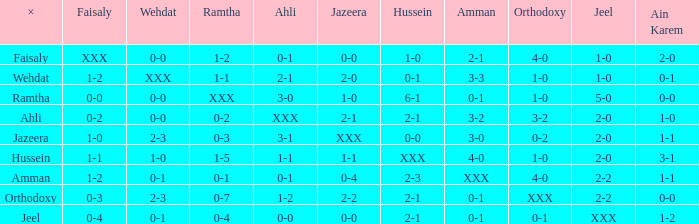Parse the full table. {'header': ['×', 'Faisaly', 'Wehdat', 'Ramtha', 'Ahli', 'Jazeera', 'Hussein', 'Amman', 'Orthodoxy', 'Jeel', 'Ain Karem'], 'rows': [['Faisaly', 'XXX', '0-0', '1-2', '0-1', '0-0', '1-0', '2-1', '4-0', '1-0', '2-0'], ['Wehdat', '1-2', 'XXX', '1-1', '2-1', '2-0', '0-1', '3-3', '1-0', '1-0', '0-1'], ['Ramtha', '0-0', '0-0', 'XXX', '3-0', '1-0', '6-1', '0-1', '1-0', '5-0', '0-0'], ['Ahli', '0-2', '0-0', '0-2', 'XXX', '2-1', '2-1', '3-2', '3-2', '2-0', '1-0'], ['Jazeera', '1-0', '2-3', '0-3', '3-1', 'XXX', '0-0', '3-0', '0-2', '2-0', '1-1'], ['Hussein', '1-1', '1-0', '1-5', '1-1', '1-1', 'XXX', '4-0', '1-0', '2-0', '3-1'], ['Amman', '1-2', '0-1', '0-1', '0-1', '0-4', '2-3', 'XXX', '4-0', '2-2', '1-1'], ['Orthodoxy', '0-3', '2-3', '0-7', '1-2', '2-2', '2-1', '0-1', 'XXX', '2-2', '0-0'], ['Jeel', '0-4', '0-1', '0-4', '0-0', '0-0', '2-1', '0-1', '0-1', 'XXX', '1-2']]} What is orthodoxy when x is wehdat? 1-0. 